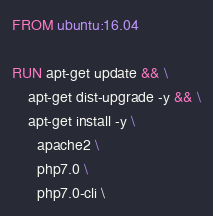<code> <loc_0><loc_0><loc_500><loc_500><_Dockerfile_>FROM ubuntu:16.04

RUN apt-get update && \
    apt-get dist-upgrade -y && \
    apt-get install -y \
      apache2 \
      php7.0 \
      php7.0-cli \</code> 